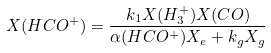Convert formula to latex. <formula><loc_0><loc_0><loc_500><loc_500>X ( H C O ^ { + } ) = \frac { k _ { 1 } X ( H _ { 3 } ^ { + } ) X ( C O ) } { \alpha ( H C O ^ { + } ) X _ { e } + k _ { g } X _ { g } }</formula> 